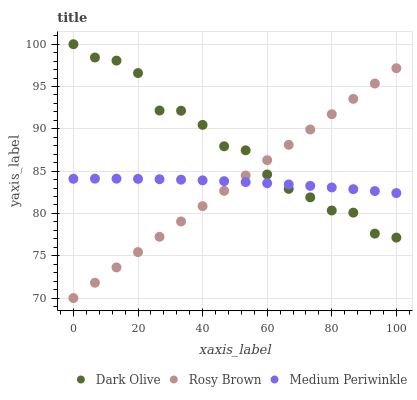Does Rosy Brown have the minimum area under the curve?
Answer yes or no. Yes. Does Dark Olive have the maximum area under the curve?
Answer yes or no. Yes. Does Medium Periwinkle have the minimum area under the curve?
Answer yes or no. No. Does Medium Periwinkle have the maximum area under the curve?
Answer yes or no. No. Is Rosy Brown the smoothest?
Answer yes or no. Yes. Is Dark Olive the roughest?
Answer yes or no. Yes. Is Medium Periwinkle the smoothest?
Answer yes or no. No. Is Medium Periwinkle the roughest?
Answer yes or no. No. Does Rosy Brown have the lowest value?
Answer yes or no. Yes. Does Dark Olive have the lowest value?
Answer yes or no. No. Does Dark Olive have the highest value?
Answer yes or no. Yes. Does Medium Periwinkle have the highest value?
Answer yes or no. No. Does Dark Olive intersect Medium Periwinkle?
Answer yes or no. Yes. Is Dark Olive less than Medium Periwinkle?
Answer yes or no. No. Is Dark Olive greater than Medium Periwinkle?
Answer yes or no. No. 